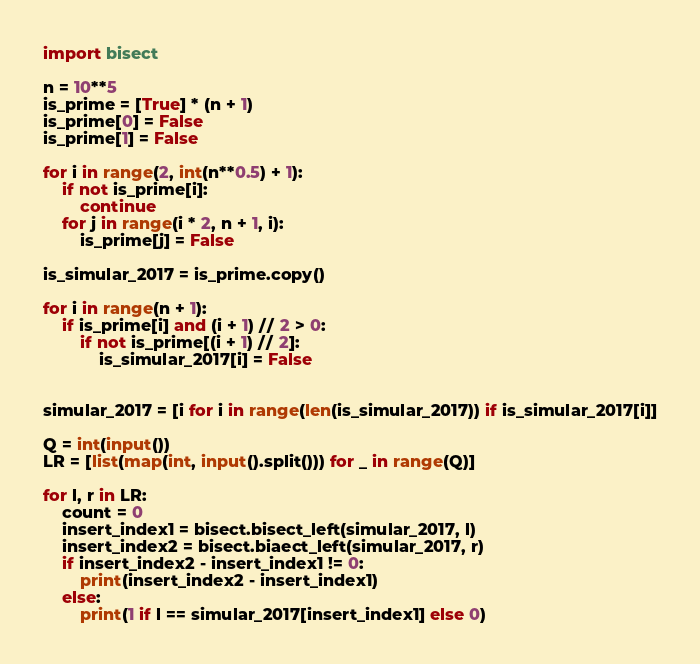<code> <loc_0><loc_0><loc_500><loc_500><_Python_>
import bisect

n = 10**5
is_prime = [True] * (n + 1)
is_prime[0] = False
is_prime[1] = False

for i in range(2, int(n**0.5) + 1):
    if not is_prime[i]:
        continue
    for j in range(i * 2, n + 1, i):
        is_prime[j] = False

is_simular_2017 = is_prime.copy()

for i in range(n + 1):
    if is_prime[i] and (i + 1) // 2 > 0:
        if not is_prime[(i + 1) // 2]:
            is_simular_2017[i] = False


simular_2017 = [i for i in range(len(is_simular_2017)) if is_simular_2017[i]]

Q = int(input())
LR = [list(map(int, input().split())) for _ in range(Q)]

for l, r in LR:
    count = 0
    insert_index1 = bisect.bisect_left(simular_2017, l)
    insert_index2 = bisect.biaect_left(simular_2017, r)
    if insert_index2 - insert_index1 != 0:
        print(insert_index2 - insert_index1)
    else:
        print(1 if l == simular_2017[insert_index1] else 0)</code> 